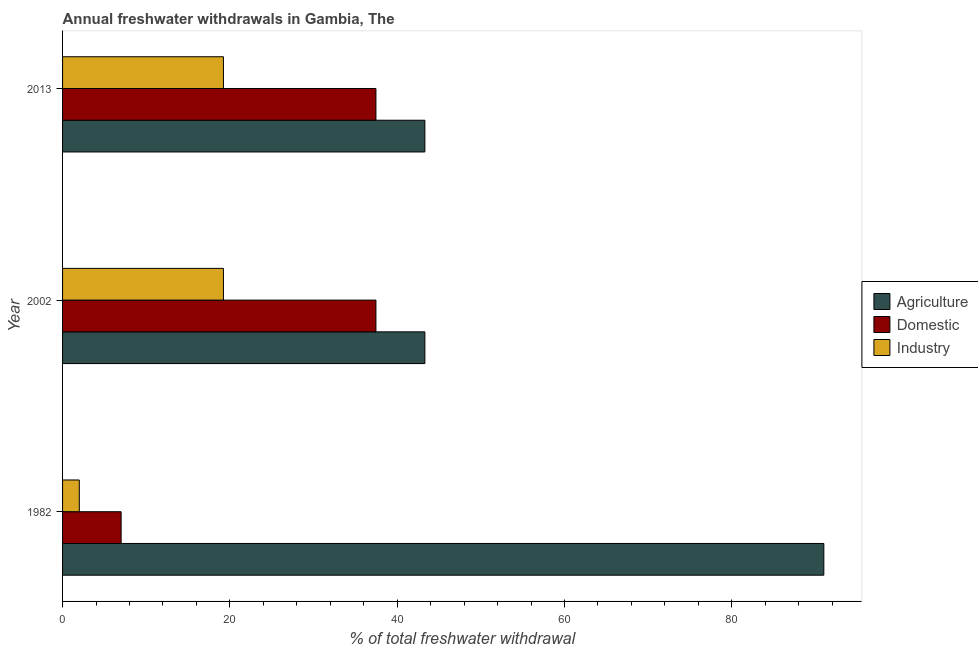How many groups of bars are there?
Ensure brevity in your answer.  3. How many bars are there on the 2nd tick from the bottom?
Offer a terse response. 3. What is the label of the 2nd group of bars from the top?
Make the answer very short. 2002. What is the percentage of freshwater withdrawal for agriculture in 2002?
Make the answer very short. 43.31. Across all years, what is the maximum percentage of freshwater withdrawal for industry?
Ensure brevity in your answer.  19.23. Across all years, what is the minimum percentage of freshwater withdrawal for agriculture?
Provide a short and direct response. 43.31. What is the total percentage of freshwater withdrawal for industry in the graph?
Give a very brief answer. 40.46. What is the difference between the percentage of freshwater withdrawal for domestic purposes in 1982 and that in 2013?
Keep it short and to the point. -30.46. What is the difference between the percentage of freshwater withdrawal for industry in 2002 and the percentage of freshwater withdrawal for agriculture in 1982?
Your answer should be very brief. -71.77. What is the average percentage of freshwater withdrawal for domestic purposes per year?
Offer a very short reply. 27.31. In the year 1982, what is the difference between the percentage of freshwater withdrawal for agriculture and percentage of freshwater withdrawal for industry?
Offer a terse response. 89. What is the ratio of the percentage of freshwater withdrawal for agriculture in 2002 to that in 2013?
Give a very brief answer. 1. Is the difference between the percentage of freshwater withdrawal for industry in 2002 and 2013 greater than the difference between the percentage of freshwater withdrawal for domestic purposes in 2002 and 2013?
Offer a terse response. No. What is the difference between the highest and the second highest percentage of freshwater withdrawal for domestic purposes?
Provide a short and direct response. 0. What is the difference between the highest and the lowest percentage of freshwater withdrawal for domestic purposes?
Give a very brief answer. 30.46. In how many years, is the percentage of freshwater withdrawal for industry greater than the average percentage of freshwater withdrawal for industry taken over all years?
Keep it short and to the point. 2. What does the 2nd bar from the top in 1982 represents?
Your answer should be compact. Domestic. What does the 3rd bar from the bottom in 2013 represents?
Your response must be concise. Industry. Are all the bars in the graph horizontal?
Give a very brief answer. Yes. How many years are there in the graph?
Provide a succinct answer. 3. What is the difference between two consecutive major ticks on the X-axis?
Offer a terse response. 20. Are the values on the major ticks of X-axis written in scientific E-notation?
Keep it short and to the point. No. Where does the legend appear in the graph?
Provide a succinct answer. Center right. What is the title of the graph?
Offer a terse response. Annual freshwater withdrawals in Gambia, The. Does "Solid fuel" appear as one of the legend labels in the graph?
Make the answer very short. No. What is the label or title of the X-axis?
Offer a very short reply. % of total freshwater withdrawal. What is the % of total freshwater withdrawal of Agriculture in 1982?
Keep it short and to the point. 91. What is the % of total freshwater withdrawal in Industry in 1982?
Provide a succinct answer. 2. What is the % of total freshwater withdrawal in Agriculture in 2002?
Make the answer very short. 43.31. What is the % of total freshwater withdrawal in Domestic in 2002?
Make the answer very short. 37.46. What is the % of total freshwater withdrawal of Industry in 2002?
Your response must be concise. 19.23. What is the % of total freshwater withdrawal of Agriculture in 2013?
Ensure brevity in your answer.  43.31. What is the % of total freshwater withdrawal in Domestic in 2013?
Your response must be concise. 37.46. What is the % of total freshwater withdrawal in Industry in 2013?
Provide a short and direct response. 19.23. Across all years, what is the maximum % of total freshwater withdrawal of Agriculture?
Keep it short and to the point. 91. Across all years, what is the maximum % of total freshwater withdrawal of Domestic?
Ensure brevity in your answer.  37.46. Across all years, what is the maximum % of total freshwater withdrawal in Industry?
Ensure brevity in your answer.  19.23. Across all years, what is the minimum % of total freshwater withdrawal of Agriculture?
Keep it short and to the point. 43.31. Across all years, what is the minimum % of total freshwater withdrawal of Domestic?
Your answer should be very brief. 7. What is the total % of total freshwater withdrawal in Agriculture in the graph?
Your answer should be compact. 177.62. What is the total % of total freshwater withdrawal in Domestic in the graph?
Keep it short and to the point. 81.92. What is the total % of total freshwater withdrawal of Industry in the graph?
Your answer should be compact. 40.46. What is the difference between the % of total freshwater withdrawal of Agriculture in 1982 and that in 2002?
Make the answer very short. 47.69. What is the difference between the % of total freshwater withdrawal of Domestic in 1982 and that in 2002?
Keep it short and to the point. -30.46. What is the difference between the % of total freshwater withdrawal in Industry in 1982 and that in 2002?
Offer a terse response. -17.23. What is the difference between the % of total freshwater withdrawal in Agriculture in 1982 and that in 2013?
Offer a very short reply. 47.69. What is the difference between the % of total freshwater withdrawal of Domestic in 1982 and that in 2013?
Make the answer very short. -30.46. What is the difference between the % of total freshwater withdrawal in Industry in 1982 and that in 2013?
Your answer should be very brief. -17.23. What is the difference between the % of total freshwater withdrawal of Agriculture in 2002 and that in 2013?
Provide a succinct answer. 0. What is the difference between the % of total freshwater withdrawal of Domestic in 2002 and that in 2013?
Give a very brief answer. 0. What is the difference between the % of total freshwater withdrawal in Agriculture in 1982 and the % of total freshwater withdrawal in Domestic in 2002?
Keep it short and to the point. 53.54. What is the difference between the % of total freshwater withdrawal in Agriculture in 1982 and the % of total freshwater withdrawal in Industry in 2002?
Provide a short and direct response. 71.77. What is the difference between the % of total freshwater withdrawal of Domestic in 1982 and the % of total freshwater withdrawal of Industry in 2002?
Make the answer very short. -12.23. What is the difference between the % of total freshwater withdrawal of Agriculture in 1982 and the % of total freshwater withdrawal of Domestic in 2013?
Your answer should be very brief. 53.54. What is the difference between the % of total freshwater withdrawal in Agriculture in 1982 and the % of total freshwater withdrawal in Industry in 2013?
Offer a terse response. 71.77. What is the difference between the % of total freshwater withdrawal of Domestic in 1982 and the % of total freshwater withdrawal of Industry in 2013?
Your answer should be compact. -12.23. What is the difference between the % of total freshwater withdrawal of Agriculture in 2002 and the % of total freshwater withdrawal of Domestic in 2013?
Offer a terse response. 5.85. What is the difference between the % of total freshwater withdrawal in Agriculture in 2002 and the % of total freshwater withdrawal in Industry in 2013?
Your response must be concise. 24.08. What is the difference between the % of total freshwater withdrawal of Domestic in 2002 and the % of total freshwater withdrawal of Industry in 2013?
Make the answer very short. 18.23. What is the average % of total freshwater withdrawal in Agriculture per year?
Offer a terse response. 59.21. What is the average % of total freshwater withdrawal in Domestic per year?
Make the answer very short. 27.31. What is the average % of total freshwater withdrawal in Industry per year?
Your answer should be very brief. 13.49. In the year 1982, what is the difference between the % of total freshwater withdrawal of Agriculture and % of total freshwater withdrawal of Industry?
Provide a short and direct response. 89. In the year 2002, what is the difference between the % of total freshwater withdrawal in Agriculture and % of total freshwater withdrawal in Domestic?
Offer a terse response. 5.85. In the year 2002, what is the difference between the % of total freshwater withdrawal of Agriculture and % of total freshwater withdrawal of Industry?
Ensure brevity in your answer.  24.08. In the year 2002, what is the difference between the % of total freshwater withdrawal of Domestic and % of total freshwater withdrawal of Industry?
Your answer should be very brief. 18.23. In the year 2013, what is the difference between the % of total freshwater withdrawal of Agriculture and % of total freshwater withdrawal of Domestic?
Offer a very short reply. 5.85. In the year 2013, what is the difference between the % of total freshwater withdrawal in Agriculture and % of total freshwater withdrawal in Industry?
Offer a very short reply. 24.08. In the year 2013, what is the difference between the % of total freshwater withdrawal in Domestic and % of total freshwater withdrawal in Industry?
Offer a very short reply. 18.23. What is the ratio of the % of total freshwater withdrawal in Agriculture in 1982 to that in 2002?
Keep it short and to the point. 2.1. What is the ratio of the % of total freshwater withdrawal of Domestic in 1982 to that in 2002?
Provide a short and direct response. 0.19. What is the ratio of the % of total freshwater withdrawal of Industry in 1982 to that in 2002?
Ensure brevity in your answer.  0.1. What is the ratio of the % of total freshwater withdrawal in Agriculture in 1982 to that in 2013?
Make the answer very short. 2.1. What is the ratio of the % of total freshwater withdrawal in Domestic in 1982 to that in 2013?
Make the answer very short. 0.19. What is the ratio of the % of total freshwater withdrawal in Industry in 1982 to that in 2013?
Offer a terse response. 0.1. What is the ratio of the % of total freshwater withdrawal of Industry in 2002 to that in 2013?
Ensure brevity in your answer.  1. What is the difference between the highest and the second highest % of total freshwater withdrawal of Agriculture?
Make the answer very short. 47.69. What is the difference between the highest and the lowest % of total freshwater withdrawal of Agriculture?
Ensure brevity in your answer.  47.69. What is the difference between the highest and the lowest % of total freshwater withdrawal in Domestic?
Your response must be concise. 30.46. What is the difference between the highest and the lowest % of total freshwater withdrawal of Industry?
Offer a terse response. 17.23. 